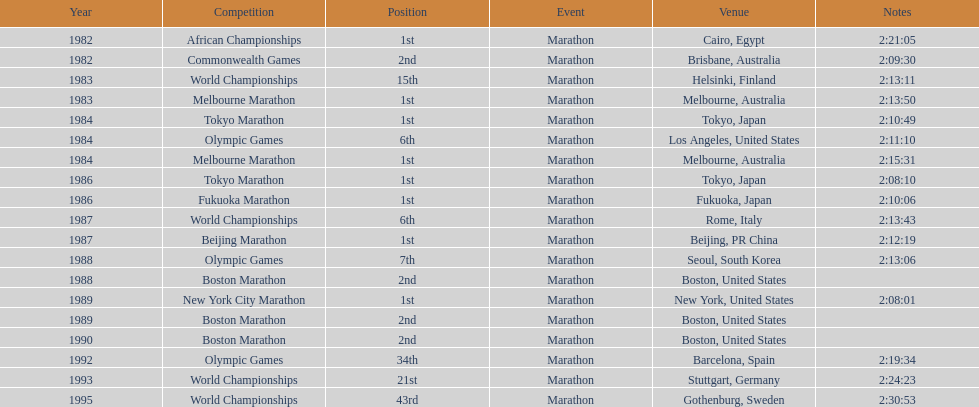What were the number of times the venue was located in the united states? 5. 